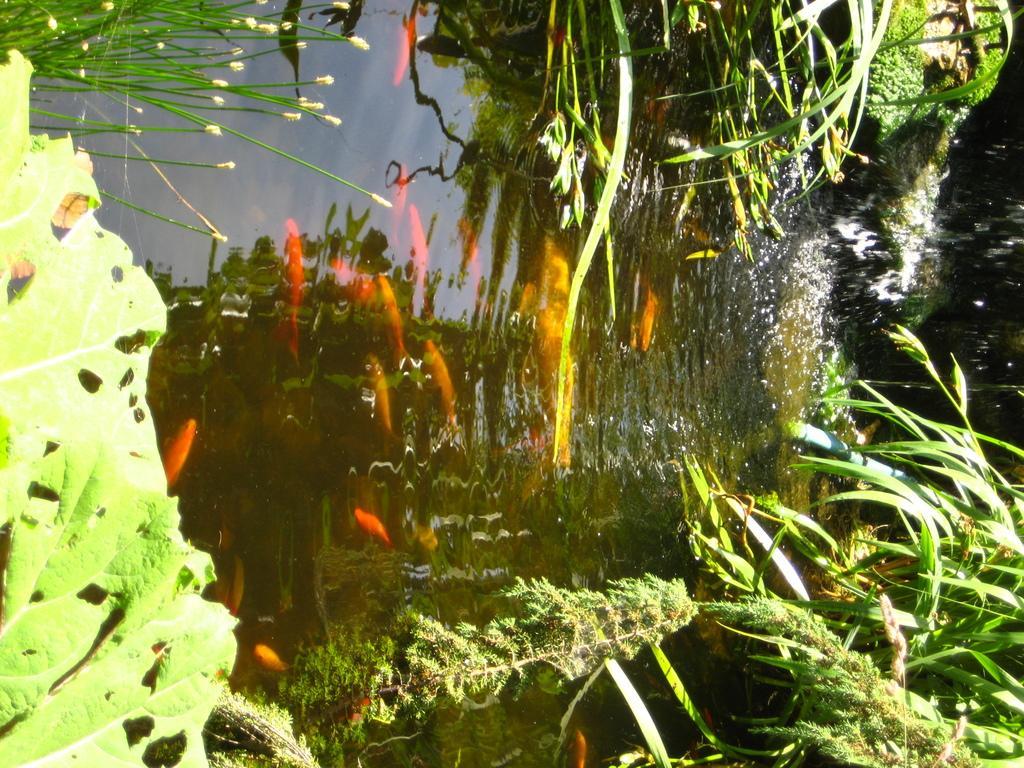Could you give a brief overview of what you see in this image? In this image I can see the grass. I can also see the fish in the water. 